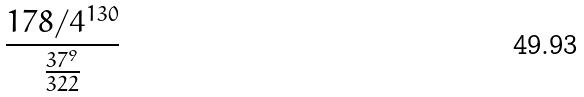Convert formula to latex. <formula><loc_0><loc_0><loc_500><loc_500>\frac { 1 7 8 / 4 ^ { 1 3 0 } } { \frac { 3 7 ^ { 9 } } { 3 2 2 } }</formula> 